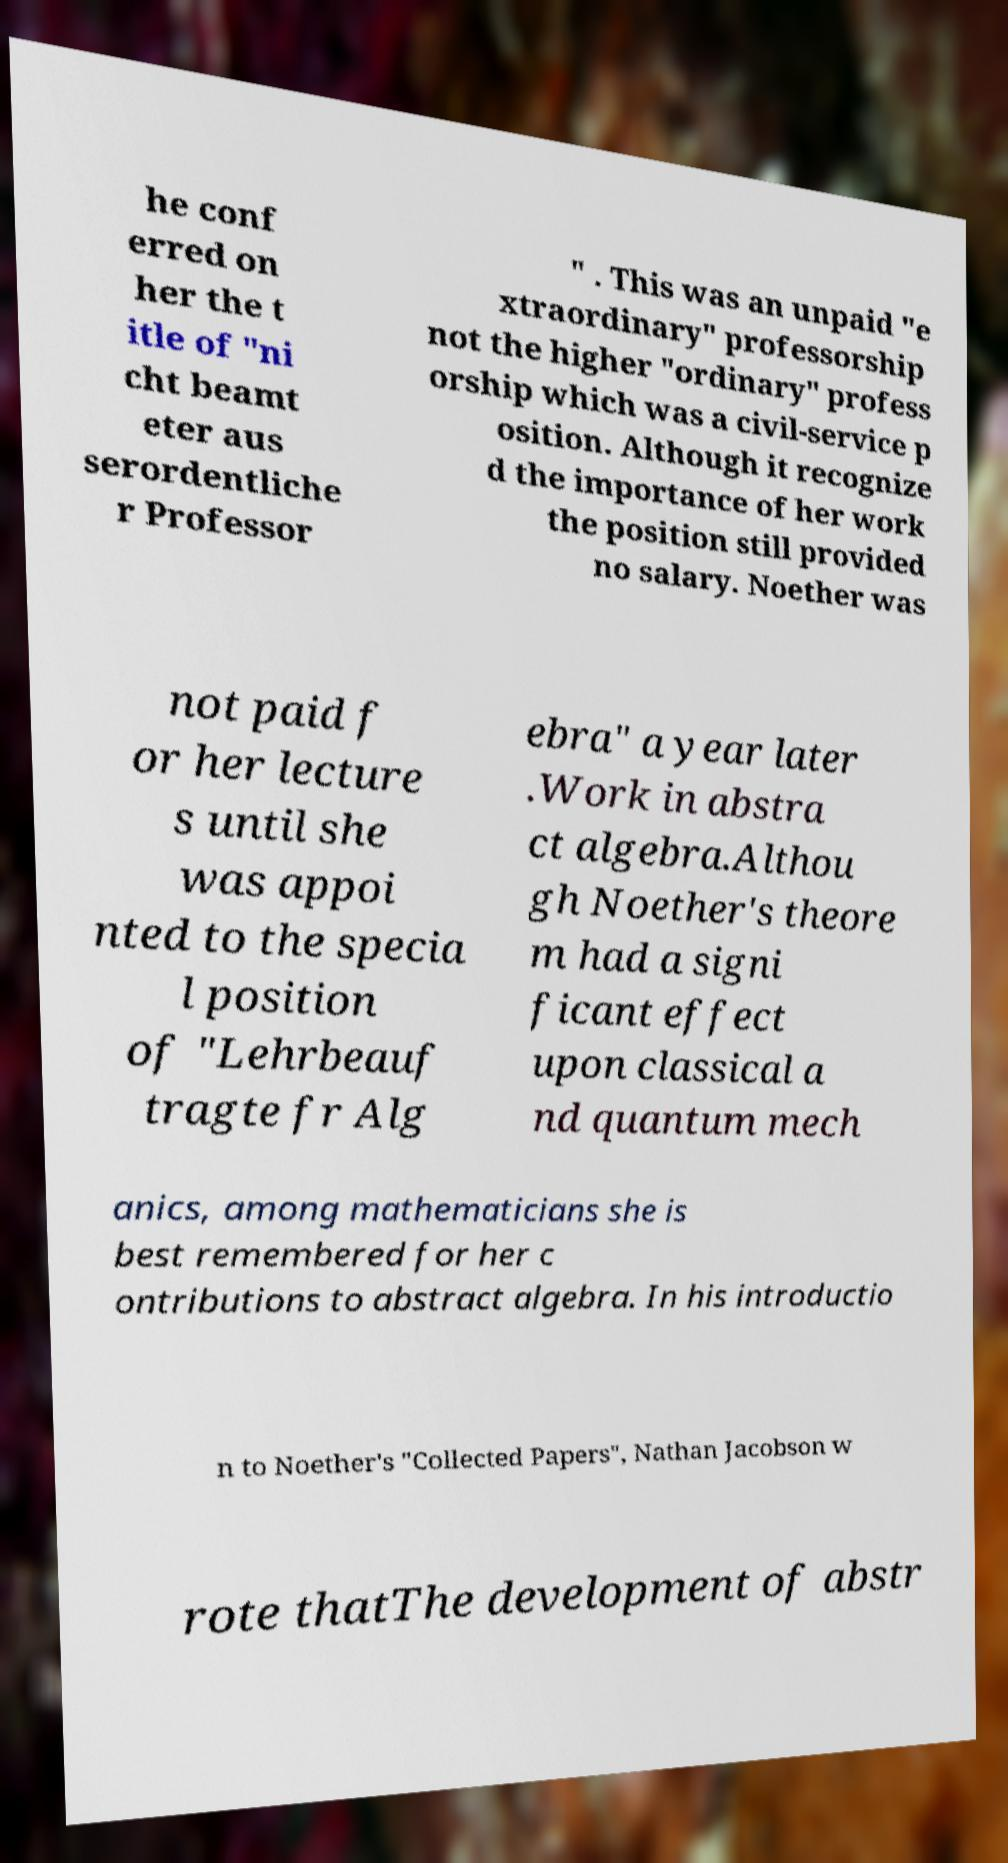For documentation purposes, I need the text within this image transcribed. Could you provide that? he conf erred on her the t itle of "ni cht beamt eter aus serordentliche r Professor " . This was an unpaid "e xtraordinary" professorship not the higher "ordinary" profess orship which was a civil-service p osition. Although it recognize d the importance of her work the position still provided no salary. Noether was not paid f or her lecture s until she was appoi nted to the specia l position of "Lehrbeauf tragte fr Alg ebra" a year later .Work in abstra ct algebra.Althou gh Noether's theore m had a signi ficant effect upon classical a nd quantum mech anics, among mathematicians she is best remembered for her c ontributions to abstract algebra. In his introductio n to Noether's "Collected Papers", Nathan Jacobson w rote thatThe development of abstr 